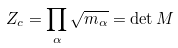<formula> <loc_0><loc_0><loc_500><loc_500>Z _ { c } = \prod _ { \alpha } \sqrt { m _ { \alpha } } = \det { M }</formula> 